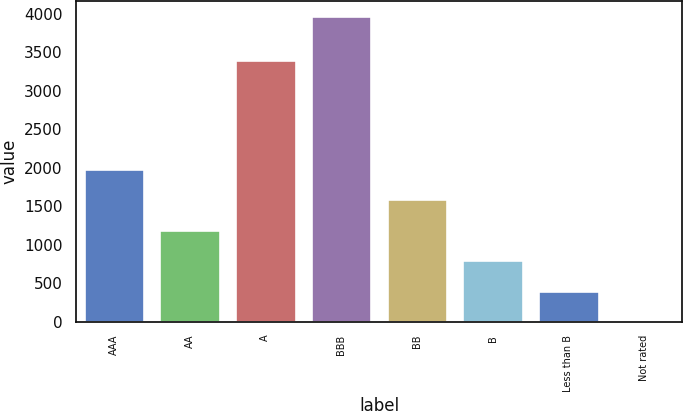<chart> <loc_0><loc_0><loc_500><loc_500><bar_chart><fcel>AAA<fcel>AA<fcel>A<fcel>BBB<fcel>BB<fcel>B<fcel>Less than B<fcel>Not rated<nl><fcel>1988.64<fcel>1194.44<fcel>3397.9<fcel>3974.1<fcel>1591.54<fcel>797.34<fcel>400.24<fcel>3.14<nl></chart> 